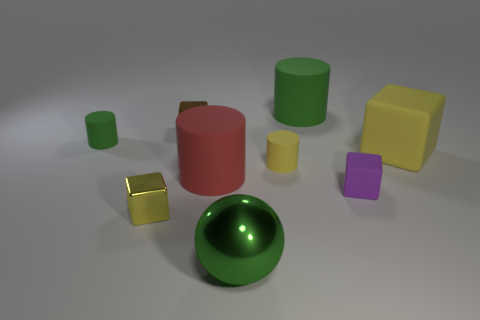Are there any other things that have the same shape as the small green thing?
Offer a terse response. Yes. What is the color of the other matte thing that is the same shape as the big yellow thing?
Provide a succinct answer. Purple. There is a large cylinder that is made of the same material as the large red thing; what is its color?
Your response must be concise. Green. Are there the same number of small purple rubber cubes left of the purple thing and large brown rubber objects?
Provide a short and direct response. Yes. There is a matte thing that is to the left of the yellow shiny object; is it the same size as the big metallic object?
Your answer should be very brief. No. There is a block that is the same size as the green metallic thing; what color is it?
Your answer should be compact. Yellow. There is a green rubber thing on the left side of the large cylinder on the right side of the sphere; are there any brown objects that are on the right side of it?
Your response must be concise. Yes. What is the large cylinder that is on the left side of the tiny yellow rubber thing made of?
Offer a very short reply. Rubber. There is a small yellow metallic thing; is its shape the same as the tiny thing that is behind the small green thing?
Make the answer very short. Yes. Are there an equal number of small metallic objects that are in front of the small green cylinder and yellow cubes in front of the red cylinder?
Keep it short and to the point. Yes. 